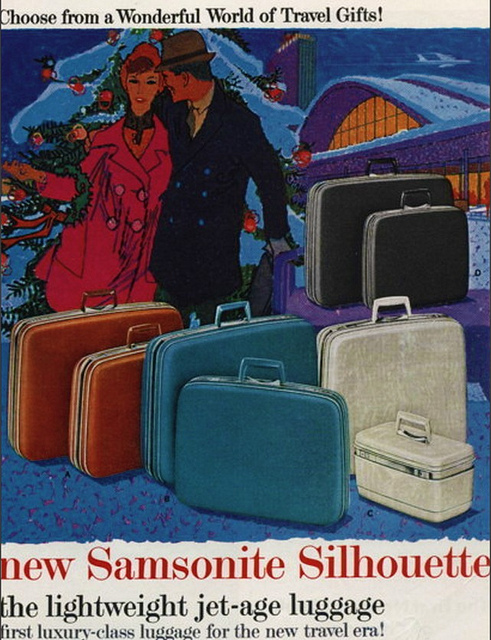How many people can be seen? The image showcases two people, likely a couple, standing closely together, poised to embark on a journey, with a festive backdrop hinting at possible holiday travel. 